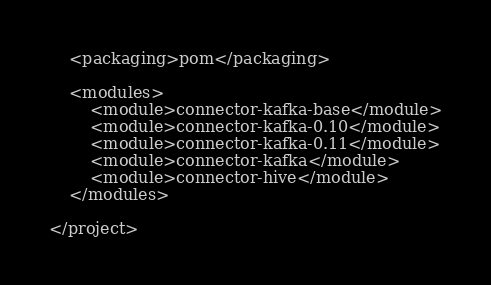<code> <loc_0><loc_0><loc_500><loc_500><_XML_>    <packaging>pom</packaging>

    <modules>
        <module>connector-kafka-base</module>
        <module>connector-kafka-0.10</module>
        <module>connector-kafka-0.11</module>
        <module>connector-kafka</module>
        <module>connector-hive</module>
    </modules>

</project>
</code> 